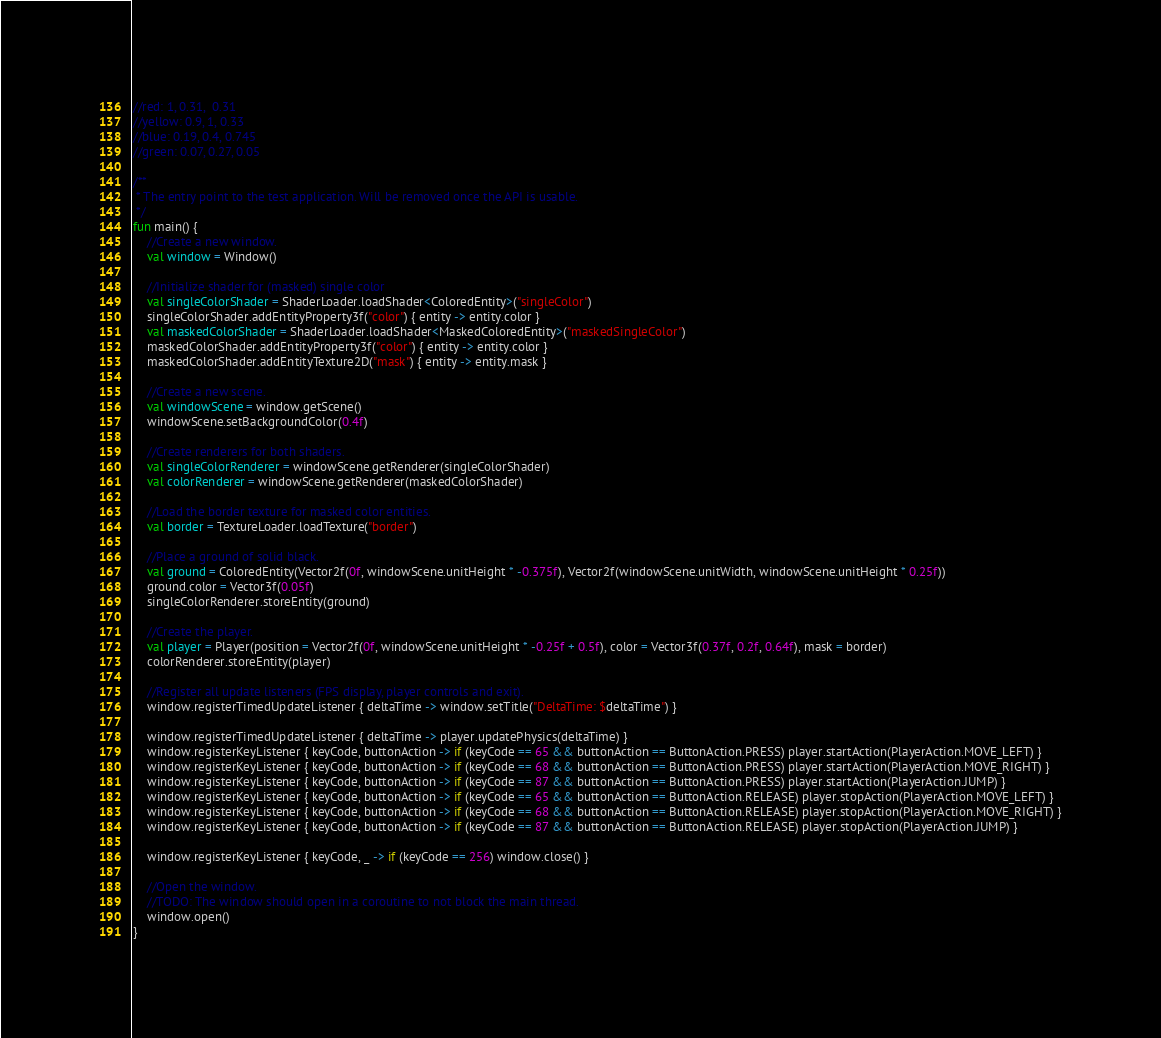Convert code to text. <code><loc_0><loc_0><loc_500><loc_500><_Kotlin_>//red: 1, 0.31,  0.31
//yellow: 0.9, 1, 0.33
//blue: 0.19, 0.4, 0.745
//green: 0.07, 0.27, 0.05

/**
 * The entry point to the test application. Will be removed once the API is usable.
 */
fun main() {
	//Create a new window.
	val window = Window()
	
	//Initialize shader for (masked) single color
	val singleColorShader = ShaderLoader.loadShader<ColoredEntity>("singleColor")
	singleColorShader.addEntityProperty3f("color") { entity -> entity.color }
	val maskedColorShader = ShaderLoader.loadShader<MaskedColoredEntity>("maskedSingleColor")
	maskedColorShader.addEntityProperty3f("color") { entity -> entity.color }
	maskedColorShader.addEntityTexture2D("mask") { entity -> entity.mask }
	
	//Create a new scene.
	val windowScene = window.getScene()
	windowScene.setBackgroundColor(0.4f)
	
	//Create renderers for both shaders.
	val singleColorRenderer = windowScene.getRenderer(singleColorShader)
	val colorRenderer = windowScene.getRenderer(maskedColorShader)
	
	//Load the border texture for masked color entities.
	val border = TextureLoader.loadTexture("border")
	
	//Place a ground of solid black.
	val ground = ColoredEntity(Vector2f(0f, windowScene.unitHeight * -0.375f), Vector2f(windowScene.unitWidth, windowScene.unitHeight * 0.25f))
	ground.color = Vector3f(0.05f)
	singleColorRenderer.storeEntity(ground)
	
	//Create the player.
	val player = Player(position = Vector2f(0f, windowScene.unitHeight * -0.25f + 0.5f), color = Vector3f(0.37f, 0.2f, 0.64f), mask = border)
	colorRenderer.storeEntity(player)
	
	//Register all update listeners (FPS display, player controls and exit).
	window.registerTimedUpdateListener { deltaTime -> window.setTitle("DeltaTime: $deltaTime") }
	
	window.registerTimedUpdateListener { deltaTime -> player.updatePhysics(deltaTime) }
	window.registerKeyListener { keyCode, buttonAction -> if (keyCode == 65 && buttonAction == ButtonAction.PRESS) player.startAction(PlayerAction.MOVE_LEFT) }
	window.registerKeyListener { keyCode, buttonAction -> if (keyCode == 68 && buttonAction == ButtonAction.PRESS) player.startAction(PlayerAction.MOVE_RIGHT) }
	window.registerKeyListener { keyCode, buttonAction -> if (keyCode == 87 && buttonAction == ButtonAction.PRESS) player.startAction(PlayerAction.JUMP) }
	window.registerKeyListener { keyCode, buttonAction -> if (keyCode == 65 && buttonAction == ButtonAction.RELEASE) player.stopAction(PlayerAction.MOVE_LEFT) }
	window.registerKeyListener { keyCode, buttonAction -> if (keyCode == 68 && buttonAction == ButtonAction.RELEASE) player.stopAction(PlayerAction.MOVE_RIGHT) }
	window.registerKeyListener { keyCode, buttonAction -> if (keyCode == 87 && buttonAction == ButtonAction.RELEASE) player.stopAction(PlayerAction.JUMP) }
	
	window.registerKeyListener { keyCode, _ -> if (keyCode == 256) window.close() }
	
	//Open the window.
	//TODO: The window should open in a coroutine to not block the main thread.
	window.open()
}
</code> 